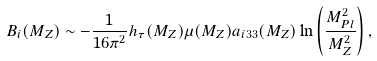Convert formula to latex. <formula><loc_0><loc_0><loc_500><loc_500>B _ { i } ( M _ { Z } ) \sim - \frac { 1 } { 1 6 \pi ^ { 2 } } h _ { \tau } ( M _ { Z } ) \mu ( M _ { Z } ) a _ { i 3 3 } ( M _ { Z } ) \ln \left ( \frac { M _ { P l } ^ { 2 } } { M _ { Z } ^ { 2 } } \right ) ,</formula> 